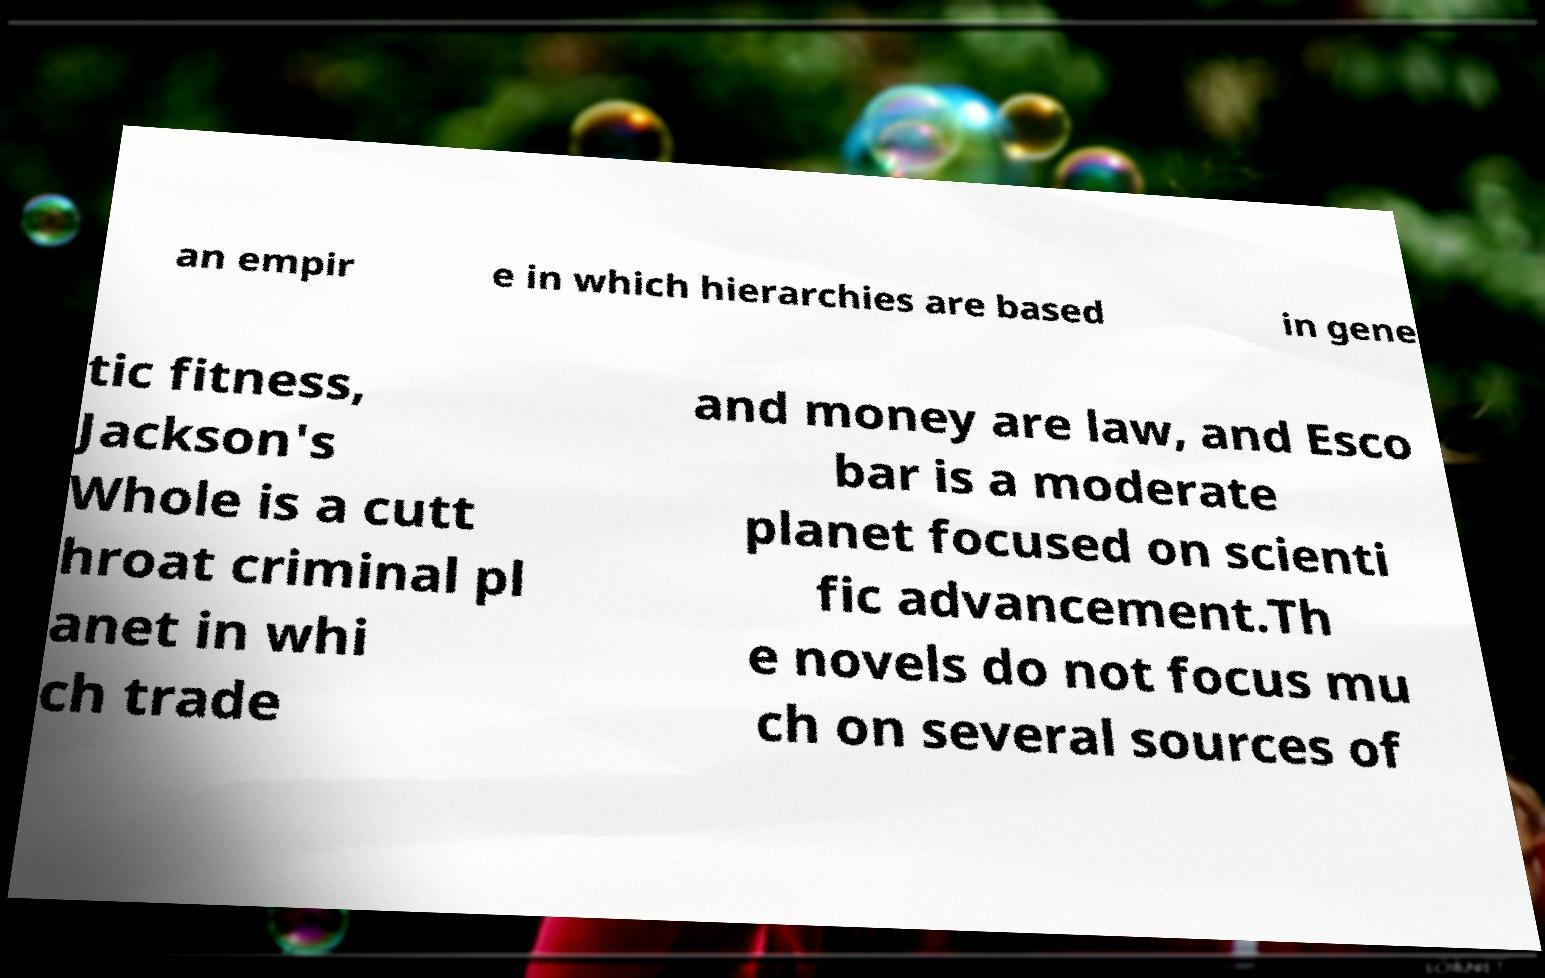Could you extract and type out the text from this image? an empir e in which hierarchies are based in gene tic fitness, Jackson's Whole is a cutt hroat criminal pl anet in whi ch trade and money are law, and Esco bar is a moderate planet focused on scienti fic advancement.Th e novels do not focus mu ch on several sources of 